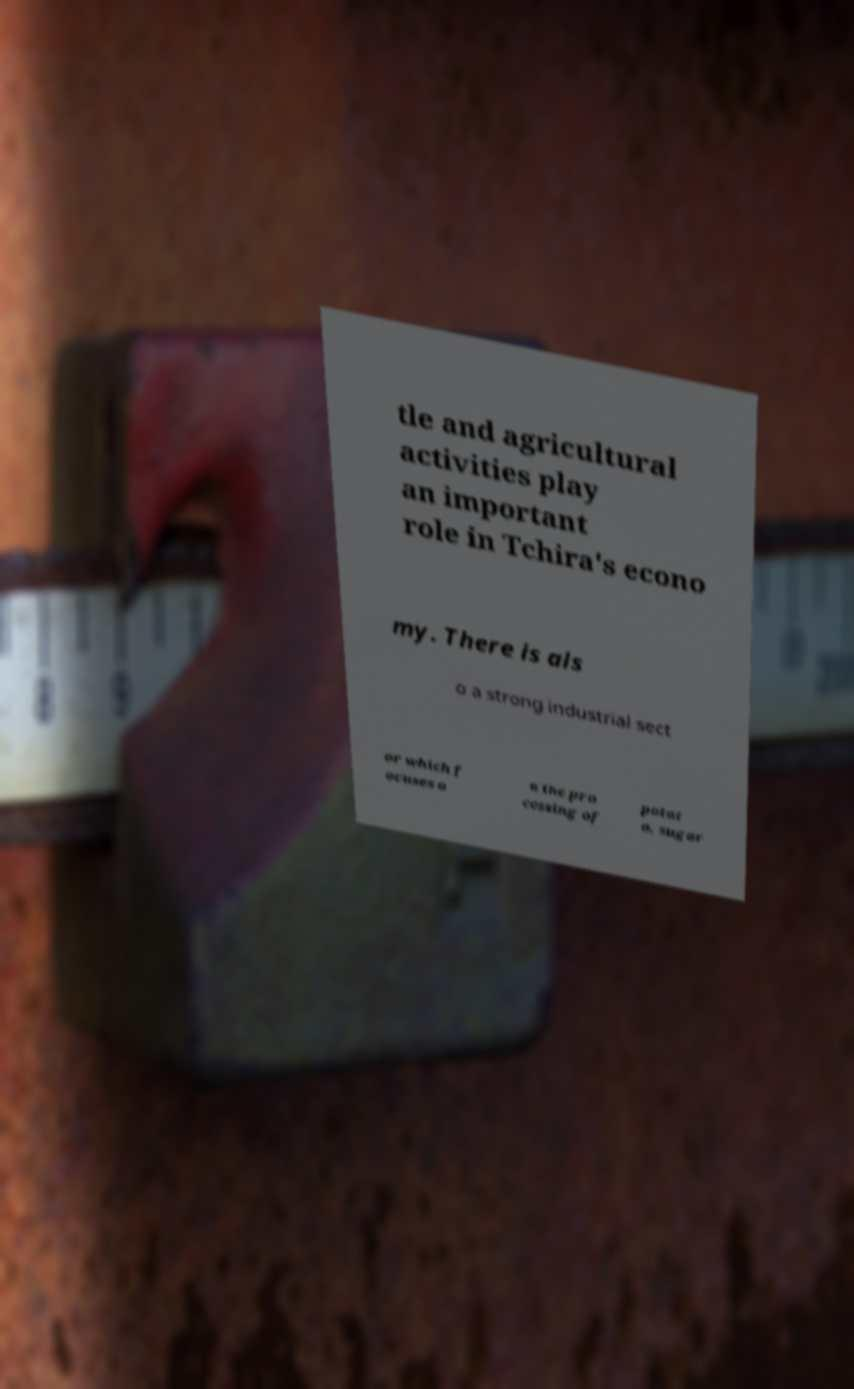Please read and relay the text visible in this image. What does it say? tle and agricultural activities play an important role in Tchira's econo my. There is als o a strong industrial sect or which f ocuses o n the pro cessing of potat o, sugar 